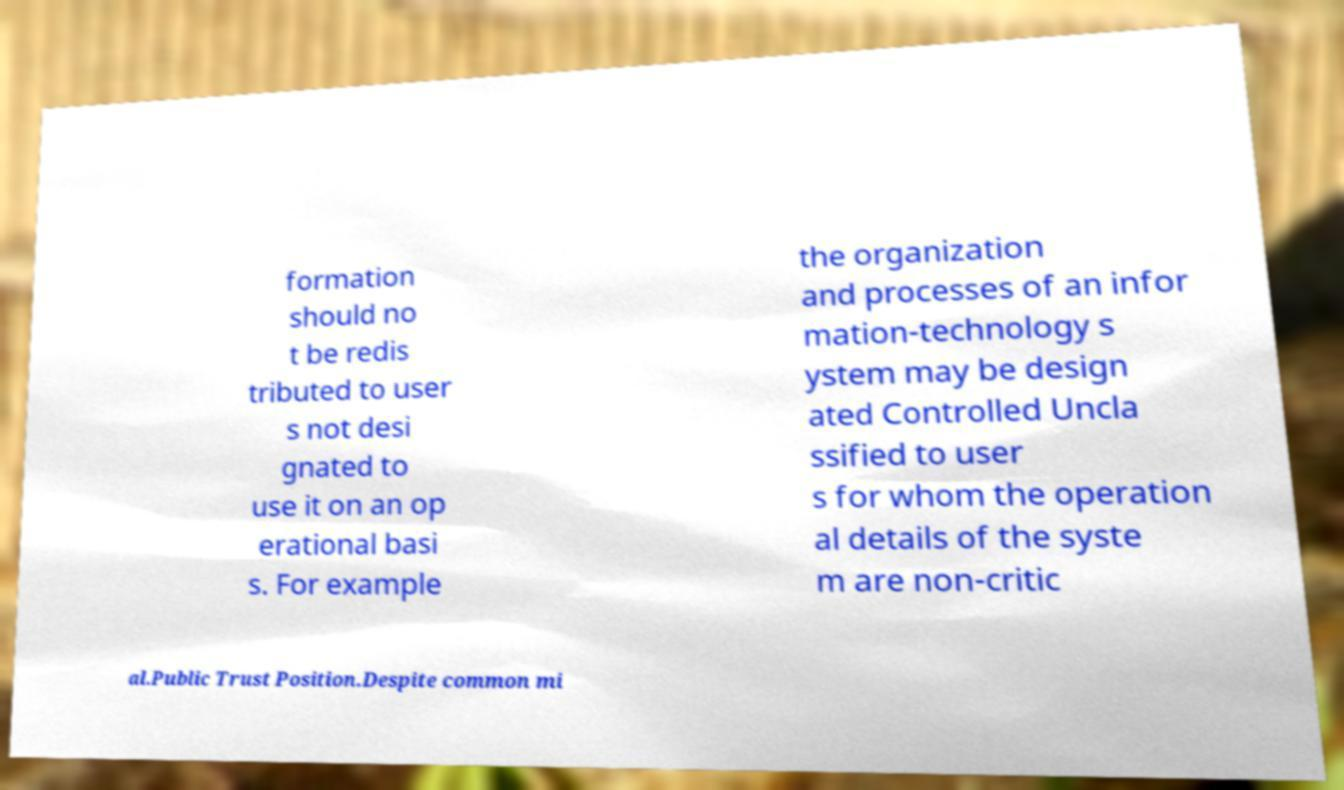Can you read and provide the text displayed in the image?This photo seems to have some interesting text. Can you extract and type it out for me? formation should no t be redis tributed to user s not desi gnated to use it on an op erational basi s. For example the organization and processes of an infor mation-technology s ystem may be design ated Controlled Uncla ssified to user s for whom the operation al details of the syste m are non-critic al.Public Trust Position.Despite common mi 